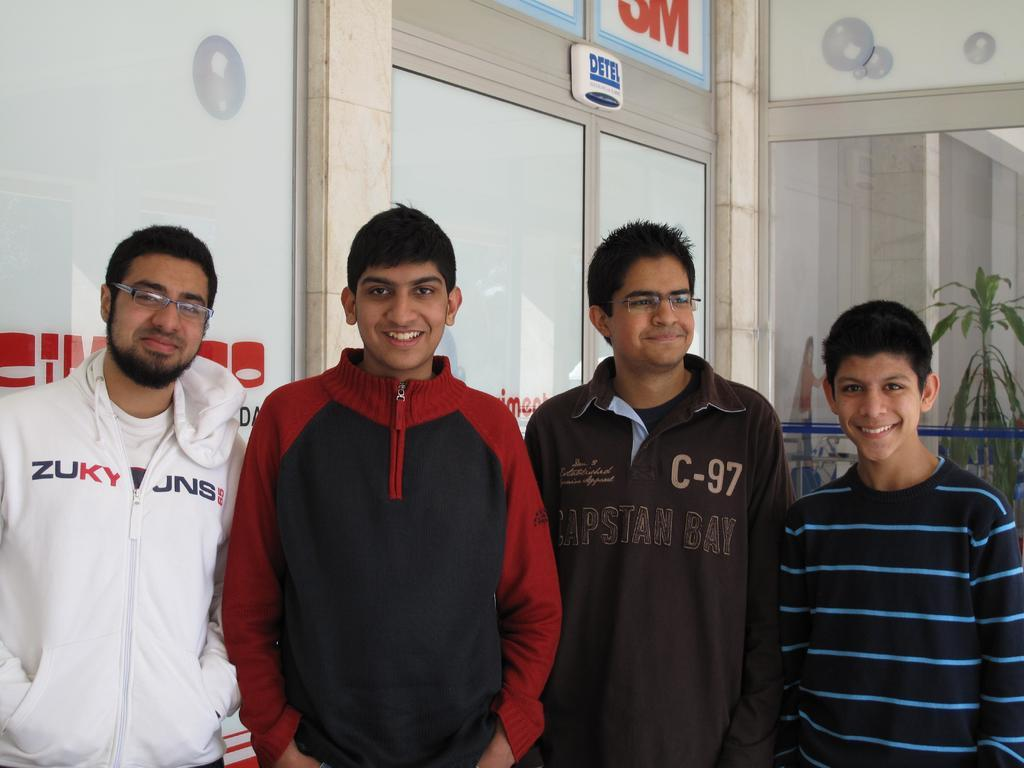Provide a one-sentence caption for the provided image. Four men stand together near a 3M store. 